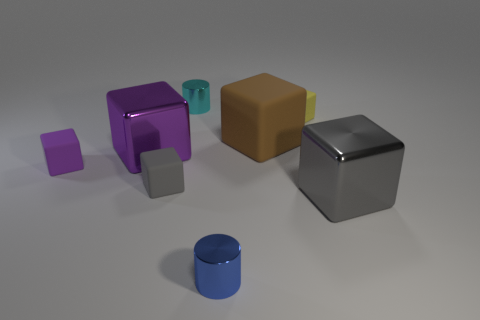Subtract all purple cubes. How many cubes are left? 4 Subtract all large purple cubes. How many cubes are left? 5 Subtract 3 cubes. How many cubes are left? 3 Subtract all red blocks. Subtract all brown cylinders. How many blocks are left? 6 Add 1 yellow matte things. How many objects exist? 9 Subtract all cylinders. How many objects are left? 6 Subtract all large yellow rubber objects. Subtract all large matte blocks. How many objects are left? 7 Add 6 purple rubber objects. How many purple rubber objects are left? 7 Add 2 yellow blocks. How many yellow blocks exist? 3 Subtract 0 blue spheres. How many objects are left? 8 